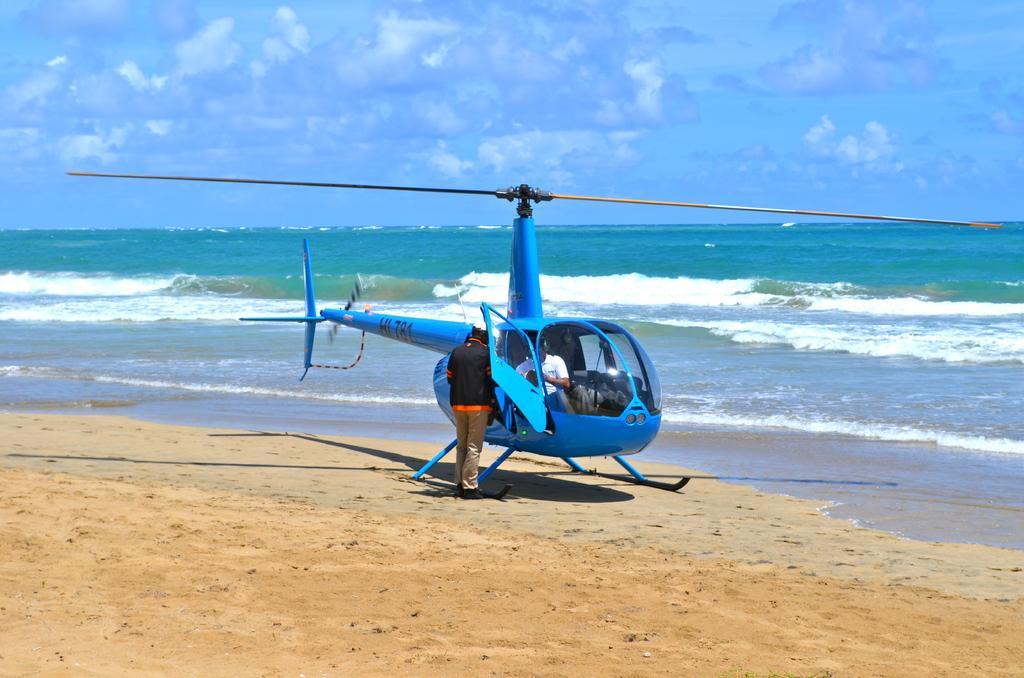Could you give a brief overview of what you see in this image? In this image we can see there is a helicopter and there is a person in it, in front of that there is a person standing. In the background there is a river and the sky. 